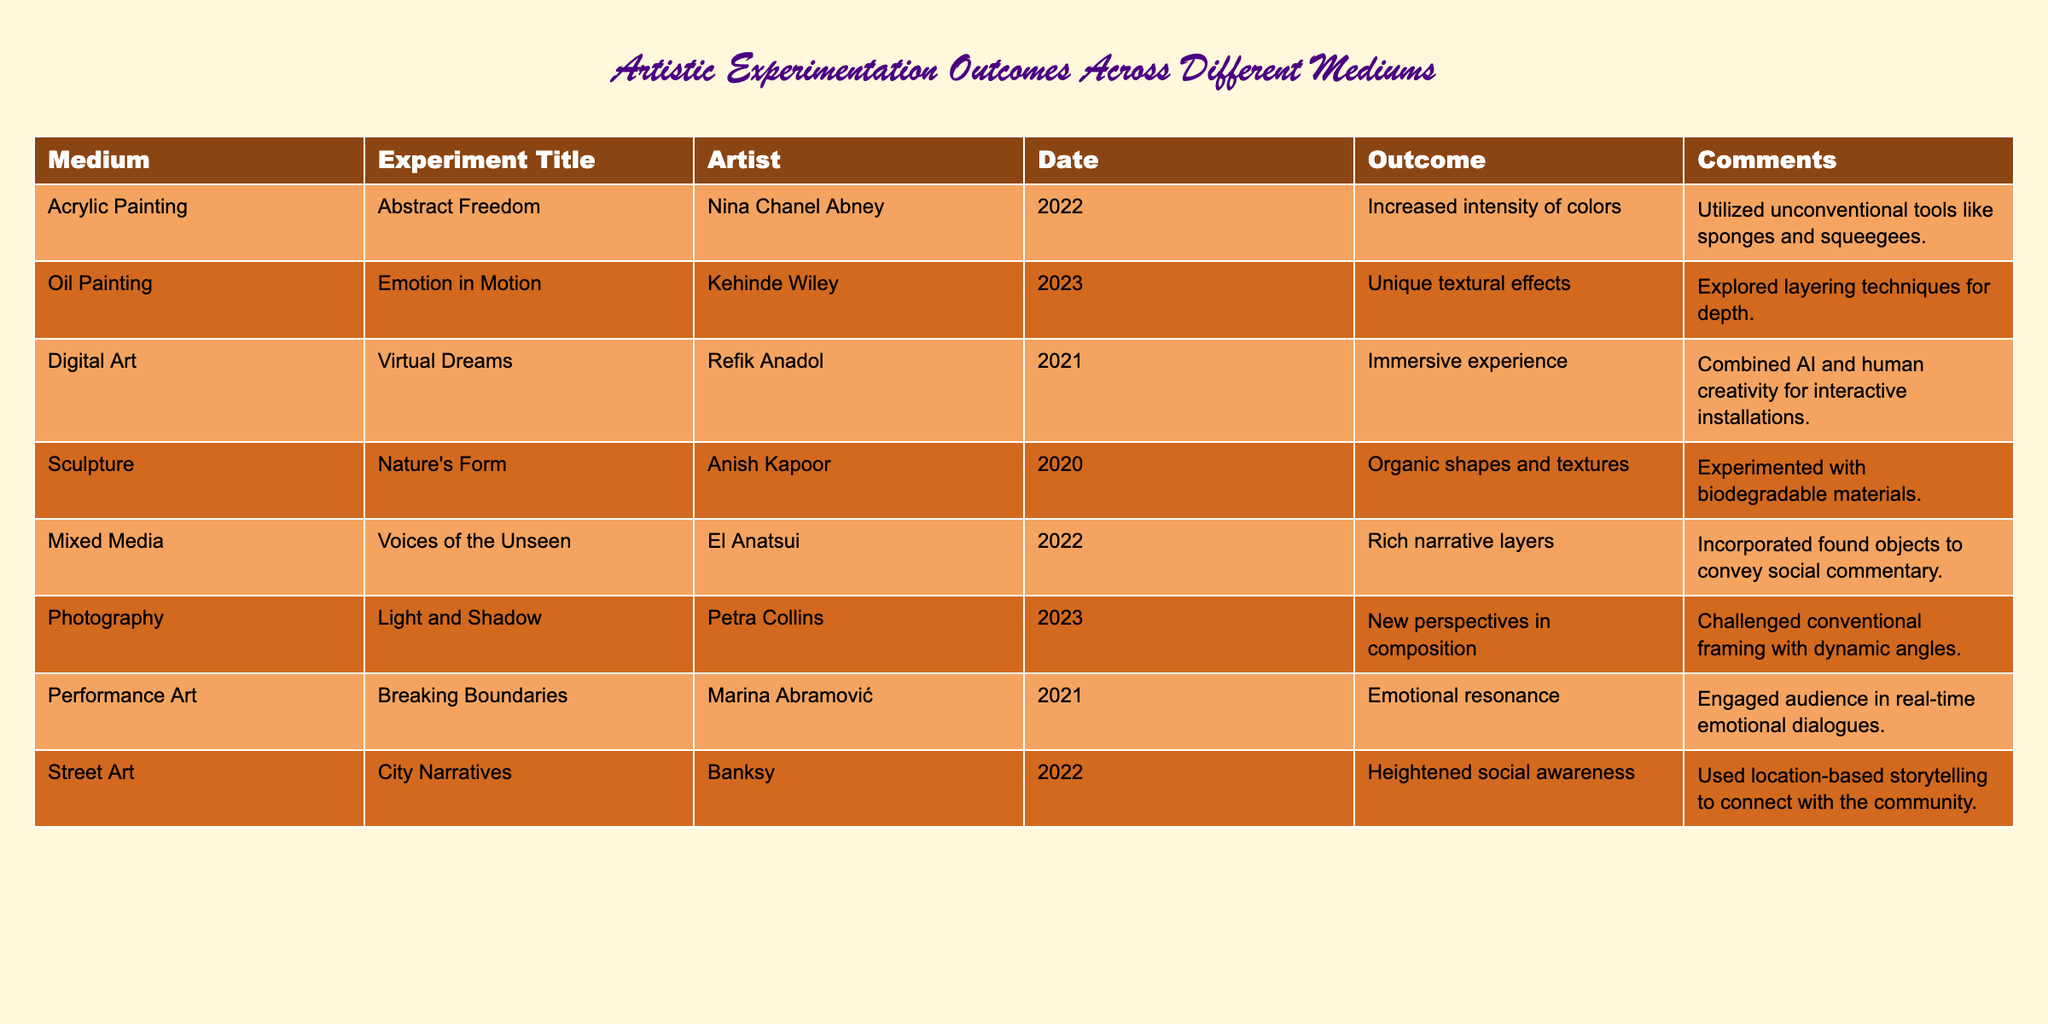What was the outcome of Kehinde Wiley's experiment? The table shows that Kehinde Wiley's experiment, titled "Emotion in Motion," resulted in "Unique textural effects." This information is directly referenced from the table under the Outcome column for that specific artist and title.
Answer: Unique textural effects Which experiment used found objects? The experiment titled "Voices of the Unseen," by El Anatsui, used found objects as stated in the Comments section of the table. I referred to the specific artist and title to locate the correct comment.
Answer: Voices of the Unseen How many different mediums are represented in the table? By counting the distinct mediums listed in the Medium column of the table, there are seven different mediums: Acrylic Painting, Oil Painting, Digital Art, Sculpture, Mixed Media, Photography, Performance Art, and Street Art.
Answer: Seven Did any experiments focus on social commentary? Yes, the table indicates that El Anatsui’s "Voices of the Unseen" incorporated found objects to convey social commentary, as noted in the Comments section. Therefore, the answer is true.
Answer: Yes Which artist experimented with interactive installations? Refik Anadol explored interactive installations in his experiment titled "Virtual Dreams," according to the table. I looked at the Artist and Comments columns to find the relevant information.
Answer: Refik Anadol What is the difference in outcomes between Oil Painting and Sculpture? The outcome for Oil Painting by Kehinde Wiley is "Unique textural effects," while for Sculpture by Anish Kapoor, it's "Organic shapes and textures." The difference shows that one focuses on texture and the other on organic forms, highlighting varied outcomes within distinct mediums.
Answer: Unique textural effects vs. Organic shapes and textures List the artists who conducted experiments in 2022. From the table, the artists who conducted experiments in 2022 include Nina Chanel Abney, El Anatsui, and Banksy. I identified the Date column and extracted the artists corresponding to that year.
Answer: Nina Chanel Abney, El Anatsui, Banksy What was the emotional impact of Marina Abramović's performance? The table describes "Breaking Boundaries" by Marina Abramović as having an "Emotional resonance," demonstrating the intended emotional impact of the performance. This information is found in the Outcome column.
Answer: Emotional resonance What is the average year of the experiments listed in the table? The years of the experiments are 2022, 2023, 2021, 2020, 2022, 2023, 2021, 2022. Summing these gives 2022 + 2023 + 2021 + 2020 + 2022 + 2023 + 2021 + 2022 = 1615, then dividing by 8 (the number of experiments) results in an average year of 2021.875. This indicates the average falls slightly below 2022 but hasn't crossed into the following year.
Answer: Approximately 2021.88 